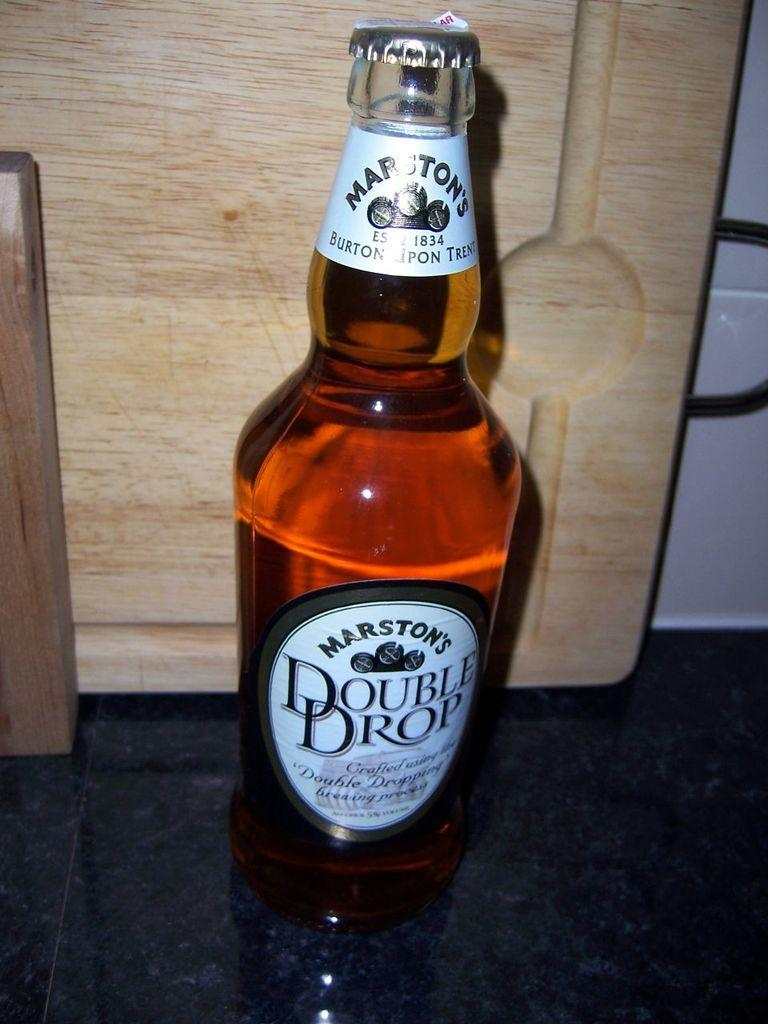<image>
Create a compact narrative representing the image presented. A bottle of Marston's Double Drop sits on a floor. 